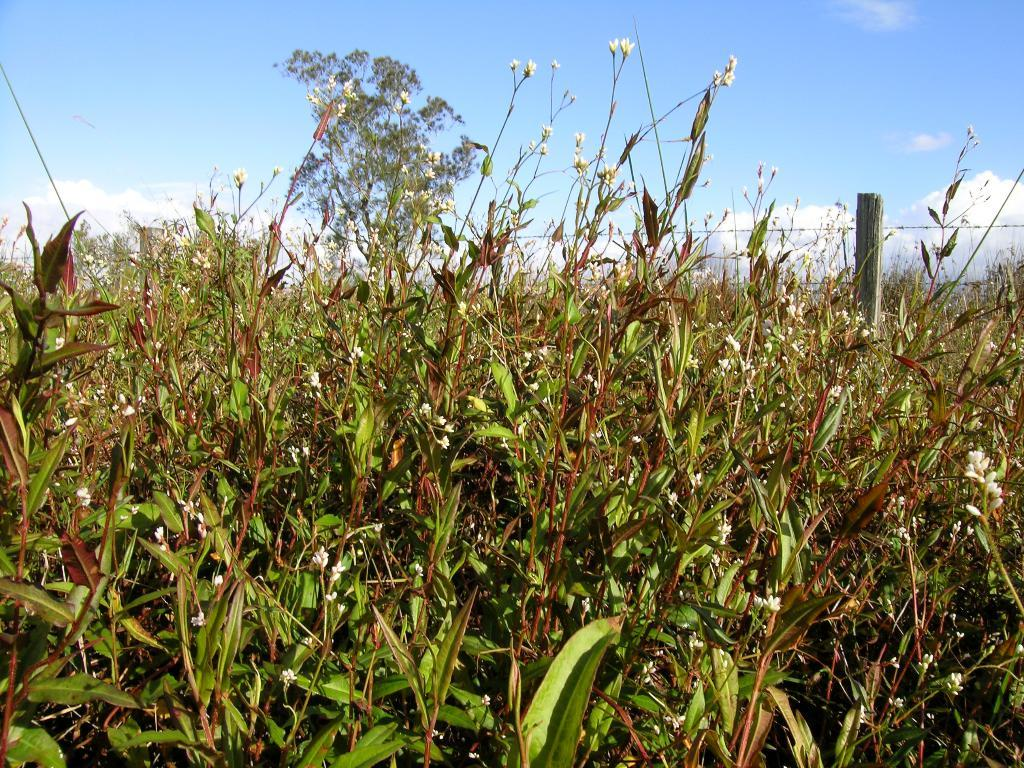What type of plants can be seen in the image? There are grass plants with flowers in the image. What structure is present in the image? There is a pole in the image. What can be seen in the background of the image? There is a tree and the sky visible in the background of the image. What is the condition of the sky in the image? Clouds are present in the sky. What type of juice is being squeezed from the edge of the canvas in the image? There is no canvas or juice present in the image. 